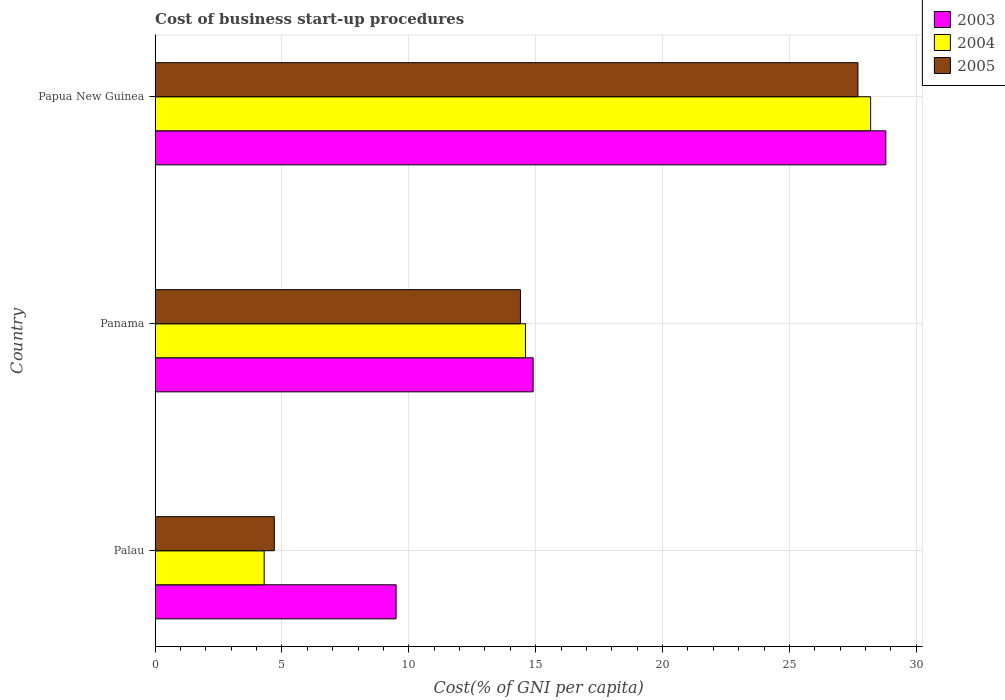Are the number of bars on each tick of the Y-axis equal?
Your answer should be compact. Yes. How many bars are there on the 3rd tick from the top?
Your answer should be compact. 3. What is the label of the 1st group of bars from the top?
Offer a very short reply. Papua New Guinea. In how many cases, is the number of bars for a given country not equal to the number of legend labels?
Your response must be concise. 0. Across all countries, what is the maximum cost of business start-up procedures in 2005?
Your response must be concise. 27.7. In which country was the cost of business start-up procedures in 2005 maximum?
Your answer should be very brief. Papua New Guinea. In which country was the cost of business start-up procedures in 2004 minimum?
Your response must be concise. Palau. What is the total cost of business start-up procedures in 2003 in the graph?
Give a very brief answer. 53.2. What is the difference between the cost of business start-up procedures in 2003 in Palau and that in Papua New Guinea?
Ensure brevity in your answer.  -19.3. What is the difference between the cost of business start-up procedures in 2005 in Panama and the cost of business start-up procedures in 2003 in Papua New Guinea?
Your answer should be compact. -14.4. In how many countries, is the cost of business start-up procedures in 2004 greater than 17 %?
Provide a succinct answer. 1. What is the ratio of the cost of business start-up procedures in 2005 in Panama to that in Papua New Guinea?
Make the answer very short. 0.52. Is the cost of business start-up procedures in 2005 in Panama less than that in Papua New Guinea?
Provide a succinct answer. Yes. What is the difference between the highest and the second highest cost of business start-up procedures in 2004?
Your answer should be compact. 13.6. What is the difference between the highest and the lowest cost of business start-up procedures in 2003?
Provide a short and direct response. 19.3. In how many countries, is the cost of business start-up procedures in 2005 greater than the average cost of business start-up procedures in 2005 taken over all countries?
Your response must be concise. 1. Are all the bars in the graph horizontal?
Provide a short and direct response. Yes. What is the difference between two consecutive major ticks on the X-axis?
Ensure brevity in your answer.  5. Are the values on the major ticks of X-axis written in scientific E-notation?
Ensure brevity in your answer.  No. Where does the legend appear in the graph?
Make the answer very short. Top right. How are the legend labels stacked?
Offer a terse response. Vertical. What is the title of the graph?
Keep it short and to the point. Cost of business start-up procedures. What is the label or title of the X-axis?
Your response must be concise. Cost(% of GNI per capita). What is the label or title of the Y-axis?
Offer a terse response. Country. What is the Cost(% of GNI per capita) in 2003 in Palau?
Offer a terse response. 9.5. What is the Cost(% of GNI per capita) of 2005 in Palau?
Your answer should be compact. 4.7. What is the Cost(% of GNI per capita) in 2003 in Panama?
Provide a short and direct response. 14.9. What is the Cost(% of GNI per capita) in 2004 in Panama?
Give a very brief answer. 14.6. What is the Cost(% of GNI per capita) of 2003 in Papua New Guinea?
Provide a succinct answer. 28.8. What is the Cost(% of GNI per capita) in 2004 in Papua New Guinea?
Provide a succinct answer. 28.2. What is the Cost(% of GNI per capita) in 2005 in Papua New Guinea?
Make the answer very short. 27.7. Across all countries, what is the maximum Cost(% of GNI per capita) of 2003?
Ensure brevity in your answer.  28.8. Across all countries, what is the maximum Cost(% of GNI per capita) of 2004?
Offer a terse response. 28.2. Across all countries, what is the maximum Cost(% of GNI per capita) in 2005?
Offer a terse response. 27.7. What is the total Cost(% of GNI per capita) of 2003 in the graph?
Provide a succinct answer. 53.2. What is the total Cost(% of GNI per capita) of 2004 in the graph?
Provide a short and direct response. 47.1. What is the total Cost(% of GNI per capita) in 2005 in the graph?
Your answer should be compact. 46.8. What is the difference between the Cost(% of GNI per capita) in 2003 in Palau and that in Papua New Guinea?
Provide a short and direct response. -19.3. What is the difference between the Cost(% of GNI per capita) in 2004 in Palau and that in Papua New Guinea?
Offer a terse response. -23.9. What is the difference between the Cost(% of GNI per capita) in 2003 in Panama and that in Papua New Guinea?
Make the answer very short. -13.9. What is the difference between the Cost(% of GNI per capita) in 2003 in Palau and the Cost(% of GNI per capita) in 2004 in Papua New Guinea?
Keep it short and to the point. -18.7. What is the difference between the Cost(% of GNI per capita) of 2003 in Palau and the Cost(% of GNI per capita) of 2005 in Papua New Guinea?
Your answer should be very brief. -18.2. What is the difference between the Cost(% of GNI per capita) of 2004 in Palau and the Cost(% of GNI per capita) of 2005 in Papua New Guinea?
Make the answer very short. -23.4. What is the difference between the Cost(% of GNI per capita) of 2003 in Panama and the Cost(% of GNI per capita) of 2005 in Papua New Guinea?
Your answer should be compact. -12.8. What is the average Cost(% of GNI per capita) of 2003 per country?
Offer a terse response. 17.73. What is the difference between the Cost(% of GNI per capita) of 2003 and Cost(% of GNI per capita) of 2004 in Palau?
Ensure brevity in your answer.  5.2. What is the difference between the Cost(% of GNI per capita) in 2004 and Cost(% of GNI per capita) in 2005 in Palau?
Ensure brevity in your answer.  -0.4. What is the difference between the Cost(% of GNI per capita) of 2003 and Cost(% of GNI per capita) of 2004 in Panama?
Give a very brief answer. 0.3. What is the difference between the Cost(% of GNI per capita) of 2003 and Cost(% of GNI per capita) of 2005 in Panama?
Your answer should be compact. 0.5. What is the difference between the Cost(% of GNI per capita) of 2004 and Cost(% of GNI per capita) of 2005 in Papua New Guinea?
Ensure brevity in your answer.  0.5. What is the ratio of the Cost(% of GNI per capita) of 2003 in Palau to that in Panama?
Offer a terse response. 0.64. What is the ratio of the Cost(% of GNI per capita) of 2004 in Palau to that in Panama?
Your response must be concise. 0.29. What is the ratio of the Cost(% of GNI per capita) of 2005 in Palau to that in Panama?
Your response must be concise. 0.33. What is the ratio of the Cost(% of GNI per capita) of 2003 in Palau to that in Papua New Guinea?
Offer a very short reply. 0.33. What is the ratio of the Cost(% of GNI per capita) of 2004 in Palau to that in Papua New Guinea?
Keep it short and to the point. 0.15. What is the ratio of the Cost(% of GNI per capita) in 2005 in Palau to that in Papua New Guinea?
Provide a short and direct response. 0.17. What is the ratio of the Cost(% of GNI per capita) of 2003 in Panama to that in Papua New Guinea?
Your response must be concise. 0.52. What is the ratio of the Cost(% of GNI per capita) of 2004 in Panama to that in Papua New Guinea?
Provide a succinct answer. 0.52. What is the ratio of the Cost(% of GNI per capita) of 2005 in Panama to that in Papua New Guinea?
Provide a short and direct response. 0.52. What is the difference between the highest and the second highest Cost(% of GNI per capita) of 2003?
Offer a terse response. 13.9. What is the difference between the highest and the second highest Cost(% of GNI per capita) in 2004?
Provide a short and direct response. 13.6. What is the difference between the highest and the second highest Cost(% of GNI per capita) in 2005?
Provide a short and direct response. 13.3. What is the difference between the highest and the lowest Cost(% of GNI per capita) in 2003?
Give a very brief answer. 19.3. What is the difference between the highest and the lowest Cost(% of GNI per capita) in 2004?
Your response must be concise. 23.9. What is the difference between the highest and the lowest Cost(% of GNI per capita) of 2005?
Give a very brief answer. 23. 